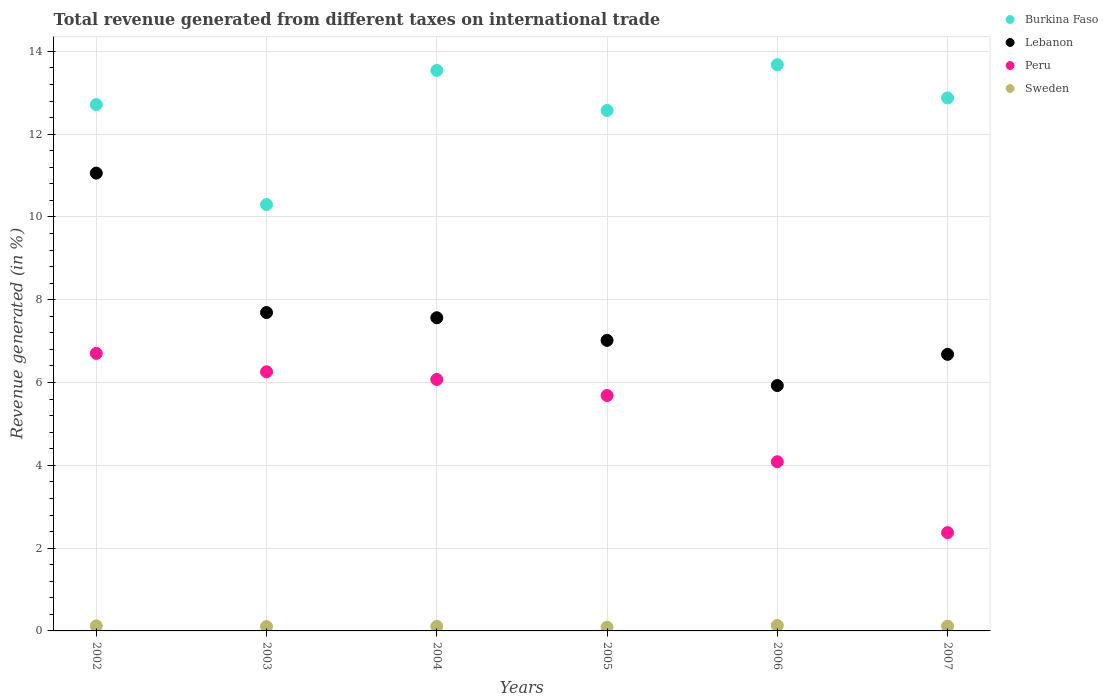How many different coloured dotlines are there?
Your response must be concise. 4. Is the number of dotlines equal to the number of legend labels?
Ensure brevity in your answer.  Yes. What is the total revenue generated in Burkina Faso in 2002?
Give a very brief answer. 12.71. Across all years, what is the maximum total revenue generated in Burkina Faso?
Ensure brevity in your answer.  13.68. Across all years, what is the minimum total revenue generated in Lebanon?
Offer a terse response. 5.93. In which year was the total revenue generated in Burkina Faso maximum?
Make the answer very short. 2006. What is the total total revenue generated in Lebanon in the graph?
Your answer should be very brief. 45.94. What is the difference between the total revenue generated in Peru in 2002 and that in 2006?
Give a very brief answer. 2.62. What is the difference between the total revenue generated in Lebanon in 2002 and the total revenue generated in Sweden in 2005?
Keep it short and to the point. 10.97. What is the average total revenue generated in Lebanon per year?
Give a very brief answer. 7.66. In the year 2004, what is the difference between the total revenue generated in Lebanon and total revenue generated in Peru?
Your response must be concise. 1.49. In how many years, is the total revenue generated in Burkina Faso greater than 4.8 %?
Make the answer very short. 6. What is the ratio of the total revenue generated in Burkina Faso in 2004 to that in 2005?
Your answer should be compact. 1.08. What is the difference between the highest and the second highest total revenue generated in Burkina Faso?
Your answer should be compact. 0.14. What is the difference between the highest and the lowest total revenue generated in Lebanon?
Offer a very short reply. 5.13. In how many years, is the total revenue generated in Sweden greater than the average total revenue generated in Sweden taken over all years?
Your response must be concise. 3. Is the sum of the total revenue generated in Peru in 2004 and 2006 greater than the maximum total revenue generated in Burkina Faso across all years?
Your answer should be compact. No. Is it the case that in every year, the sum of the total revenue generated in Burkina Faso and total revenue generated in Lebanon  is greater than the sum of total revenue generated in Peru and total revenue generated in Sweden?
Give a very brief answer. Yes. Is the total revenue generated in Sweden strictly less than the total revenue generated in Peru over the years?
Ensure brevity in your answer.  Yes. How many dotlines are there?
Your answer should be very brief. 4. Are the values on the major ticks of Y-axis written in scientific E-notation?
Your answer should be compact. No. Does the graph contain grids?
Keep it short and to the point. Yes. Where does the legend appear in the graph?
Ensure brevity in your answer.  Top right. What is the title of the graph?
Give a very brief answer. Total revenue generated from different taxes on international trade. What is the label or title of the Y-axis?
Keep it short and to the point. Revenue generated (in %). What is the Revenue generated (in %) of Burkina Faso in 2002?
Provide a succinct answer. 12.71. What is the Revenue generated (in %) of Lebanon in 2002?
Your answer should be very brief. 11.06. What is the Revenue generated (in %) of Peru in 2002?
Provide a succinct answer. 6.7. What is the Revenue generated (in %) of Sweden in 2002?
Your answer should be very brief. 0.12. What is the Revenue generated (in %) of Burkina Faso in 2003?
Your response must be concise. 10.3. What is the Revenue generated (in %) of Lebanon in 2003?
Provide a succinct answer. 7.69. What is the Revenue generated (in %) in Peru in 2003?
Provide a succinct answer. 6.26. What is the Revenue generated (in %) of Sweden in 2003?
Provide a succinct answer. 0.11. What is the Revenue generated (in %) of Burkina Faso in 2004?
Keep it short and to the point. 13.54. What is the Revenue generated (in %) in Lebanon in 2004?
Provide a succinct answer. 7.57. What is the Revenue generated (in %) in Peru in 2004?
Ensure brevity in your answer.  6.08. What is the Revenue generated (in %) in Sweden in 2004?
Offer a terse response. 0.11. What is the Revenue generated (in %) in Burkina Faso in 2005?
Give a very brief answer. 12.57. What is the Revenue generated (in %) of Lebanon in 2005?
Give a very brief answer. 7.02. What is the Revenue generated (in %) of Peru in 2005?
Make the answer very short. 5.69. What is the Revenue generated (in %) of Sweden in 2005?
Provide a short and direct response. 0.09. What is the Revenue generated (in %) in Burkina Faso in 2006?
Ensure brevity in your answer.  13.68. What is the Revenue generated (in %) in Lebanon in 2006?
Give a very brief answer. 5.93. What is the Revenue generated (in %) in Peru in 2006?
Your answer should be compact. 4.09. What is the Revenue generated (in %) in Sweden in 2006?
Your answer should be very brief. 0.13. What is the Revenue generated (in %) of Burkina Faso in 2007?
Offer a very short reply. 12.88. What is the Revenue generated (in %) in Lebanon in 2007?
Give a very brief answer. 6.68. What is the Revenue generated (in %) of Peru in 2007?
Offer a terse response. 2.37. What is the Revenue generated (in %) in Sweden in 2007?
Your answer should be compact. 0.11. Across all years, what is the maximum Revenue generated (in %) in Burkina Faso?
Provide a succinct answer. 13.68. Across all years, what is the maximum Revenue generated (in %) of Lebanon?
Your answer should be very brief. 11.06. Across all years, what is the maximum Revenue generated (in %) in Peru?
Offer a very short reply. 6.7. Across all years, what is the maximum Revenue generated (in %) in Sweden?
Your answer should be very brief. 0.13. Across all years, what is the minimum Revenue generated (in %) in Burkina Faso?
Give a very brief answer. 10.3. Across all years, what is the minimum Revenue generated (in %) of Lebanon?
Ensure brevity in your answer.  5.93. Across all years, what is the minimum Revenue generated (in %) of Peru?
Make the answer very short. 2.37. Across all years, what is the minimum Revenue generated (in %) in Sweden?
Provide a short and direct response. 0.09. What is the total Revenue generated (in %) in Burkina Faso in the graph?
Make the answer very short. 75.68. What is the total Revenue generated (in %) of Lebanon in the graph?
Give a very brief answer. 45.94. What is the total Revenue generated (in %) in Peru in the graph?
Give a very brief answer. 31.19. What is the total Revenue generated (in %) in Sweden in the graph?
Provide a succinct answer. 0.67. What is the difference between the Revenue generated (in %) in Burkina Faso in 2002 and that in 2003?
Provide a succinct answer. 2.41. What is the difference between the Revenue generated (in %) of Lebanon in 2002 and that in 2003?
Offer a terse response. 3.37. What is the difference between the Revenue generated (in %) of Peru in 2002 and that in 2003?
Ensure brevity in your answer.  0.44. What is the difference between the Revenue generated (in %) of Sweden in 2002 and that in 2003?
Give a very brief answer. 0.02. What is the difference between the Revenue generated (in %) of Burkina Faso in 2002 and that in 2004?
Give a very brief answer. -0.83. What is the difference between the Revenue generated (in %) of Lebanon in 2002 and that in 2004?
Provide a succinct answer. 3.49. What is the difference between the Revenue generated (in %) of Peru in 2002 and that in 2004?
Give a very brief answer. 0.63. What is the difference between the Revenue generated (in %) of Sweden in 2002 and that in 2004?
Offer a terse response. 0.01. What is the difference between the Revenue generated (in %) of Burkina Faso in 2002 and that in 2005?
Your response must be concise. 0.14. What is the difference between the Revenue generated (in %) in Lebanon in 2002 and that in 2005?
Offer a very short reply. 4.04. What is the difference between the Revenue generated (in %) of Peru in 2002 and that in 2005?
Your response must be concise. 1.02. What is the difference between the Revenue generated (in %) of Sweden in 2002 and that in 2005?
Offer a terse response. 0.03. What is the difference between the Revenue generated (in %) in Burkina Faso in 2002 and that in 2006?
Provide a short and direct response. -0.96. What is the difference between the Revenue generated (in %) of Lebanon in 2002 and that in 2006?
Your response must be concise. 5.13. What is the difference between the Revenue generated (in %) in Peru in 2002 and that in 2006?
Make the answer very short. 2.62. What is the difference between the Revenue generated (in %) in Sweden in 2002 and that in 2006?
Your response must be concise. -0.01. What is the difference between the Revenue generated (in %) in Burkina Faso in 2002 and that in 2007?
Your answer should be compact. -0.16. What is the difference between the Revenue generated (in %) of Lebanon in 2002 and that in 2007?
Your answer should be very brief. 4.38. What is the difference between the Revenue generated (in %) in Peru in 2002 and that in 2007?
Your response must be concise. 4.33. What is the difference between the Revenue generated (in %) of Sweden in 2002 and that in 2007?
Ensure brevity in your answer.  0.01. What is the difference between the Revenue generated (in %) in Burkina Faso in 2003 and that in 2004?
Give a very brief answer. -3.24. What is the difference between the Revenue generated (in %) of Lebanon in 2003 and that in 2004?
Make the answer very short. 0.13. What is the difference between the Revenue generated (in %) in Peru in 2003 and that in 2004?
Make the answer very short. 0.19. What is the difference between the Revenue generated (in %) of Sweden in 2003 and that in 2004?
Your answer should be compact. -0. What is the difference between the Revenue generated (in %) in Burkina Faso in 2003 and that in 2005?
Make the answer very short. -2.27. What is the difference between the Revenue generated (in %) in Lebanon in 2003 and that in 2005?
Offer a very short reply. 0.67. What is the difference between the Revenue generated (in %) of Peru in 2003 and that in 2005?
Make the answer very short. 0.57. What is the difference between the Revenue generated (in %) in Sweden in 2003 and that in 2005?
Give a very brief answer. 0.02. What is the difference between the Revenue generated (in %) of Burkina Faso in 2003 and that in 2006?
Provide a short and direct response. -3.38. What is the difference between the Revenue generated (in %) in Lebanon in 2003 and that in 2006?
Ensure brevity in your answer.  1.76. What is the difference between the Revenue generated (in %) in Peru in 2003 and that in 2006?
Give a very brief answer. 2.17. What is the difference between the Revenue generated (in %) of Sweden in 2003 and that in 2006?
Make the answer very short. -0.03. What is the difference between the Revenue generated (in %) in Burkina Faso in 2003 and that in 2007?
Your answer should be very brief. -2.58. What is the difference between the Revenue generated (in %) in Lebanon in 2003 and that in 2007?
Your answer should be very brief. 1.01. What is the difference between the Revenue generated (in %) in Peru in 2003 and that in 2007?
Ensure brevity in your answer.  3.89. What is the difference between the Revenue generated (in %) in Sweden in 2003 and that in 2007?
Your answer should be very brief. -0.01. What is the difference between the Revenue generated (in %) in Burkina Faso in 2004 and that in 2005?
Offer a terse response. 0.97. What is the difference between the Revenue generated (in %) in Lebanon in 2004 and that in 2005?
Your answer should be very brief. 0.55. What is the difference between the Revenue generated (in %) of Peru in 2004 and that in 2005?
Ensure brevity in your answer.  0.39. What is the difference between the Revenue generated (in %) of Sweden in 2004 and that in 2005?
Provide a succinct answer. 0.02. What is the difference between the Revenue generated (in %) of Burkina Faso in 2004 and that in 2006?
Offer a very short reply. -0.14. What is the difference between the Revenue generated (in %) of Lebanon in 2004 and that in 2006?
Offer a very short reply. 1.64. What is the difference between the Revenue generated (in %) in Peru in 2004 and that in 2006?
Your response must be concise. 1.99. What is the difference between the Revenue generated (in %) in Sweden in 2004 and that in 2006?
Keep it short and to the point. -0.02. What is the difference between the Revenue generated (in %) in Burkina Faso in 2004 and that in 2007?
Make the answer very short. 0.67. What is the difference between the Revenue generated (in %) of Lebanon in 2004 and that in 2007?
Your answer should be compact. 0.88. What is the difference between the Revenue generated (in %) in Peru in 2004 and that in 2007?
Offer a very short reply. 3.7. What is the difference between the Revenue generated (in %) in Sweden in 2004 and that in 2007?
Your answer should be compact. -0.01. What is the difference between the Revenue generated (in %) in Burkina Faso in 2005 and that in 2006?
Make the answer very short. -1.11. What is the difference between the Revenue generated (in %) of Lebanon in 2005 and that in 2006?
Provide a succinct answer. 1.09. What is the difference between the Revenue generated (in %) in Peru in 2005 and that in 2006?
Offer a very short reply. 1.6. What is the difference between the Revenue generated (in %) of Sweden in 2005 and that in 2006?
Offer a very short reply. -0.04. What is the difference between the Revenue generated (in %) of Burkina Faso in 2005 and that in 2007?
Give a very brief answer. -0.3. What is the difference between the Revenue generated (in %) in Lebanon in 2005 and that in 2007?
Provide a succinct answer. 0.34. What is the difference between the Revenue generated (in %) of Peru in 2005 and that in 2007?
Make the answer very short. 3.31. What is the difference between the Revenue generated (in %) in Sweden in 2005 and that in 2007?
Keep it short and to the point. -0.02. What is the difference between the Revenue generated (in %) of Burkina Faso in 2006 and that in 2007?
Your response must be concise. 0.8. What is the difference between the Revenue generated (in %) in Lebanon in 2006 and that in 2007?
Ensure brevity in your answer.  -0.75. What is the difference between the Revenue generated (in %) of Peru in 2006 and that in 2007?
Your response must be concise. 1.71. What is the difference between the Revenue generated (in %) in Sweden in 2006 and that in 2007?
Your answer should be compact. 0.02. What is the difference between the Revenue generated (in %) of Burkina Faso in 2002 and the Revenue generated (in %) of Lebanon in 2003?
Offer a terse response. 5.02. What is the difference between the Revenue generated (in %) in Burkina Faso in 2002 and the Revenue generated (in %) in Peru in 2003?
Provide a short and direct response. 6.45. What is the difference between the Revenue generated (in %) of Burkina Faso in 2002 and the Revenue generated (in %) of Sweden in 2003?
Provide a succinct answer. 12.61. What is the difference between the Revenue generated (in %) in Lebanon in 2002 and the Revenue generated (in %) in Peru in 2003?
Provide a succinct answer. 4.8. What is the difference between the Revenue generated (in %) of Lebanon in 2002 and the Revenue generated (in %) of Sweden in 2003?
Ensure brevity in your answer.  10.95. What is the difference between the Revenue generated (in %) of Peru in 2002 and the Revenue generated (in %) of Sweden in 2003?
Offer a terse response. 6.6. What is the difference between the Revenue generated (in %) in Burkina Faso in 2002 and the Revenue generated (in %) in Lebanon in 2004?
Offer a very short reply. 5.15. What is the difference between the Revenue generated (in %) of Burkina Faso in 2002 and the Revenue generated (in %) of Peru in 2004?
Give a very brief answer. 6.64. What is the difference between the Revenue generated (in %) of Burkina Faso in 2002 and the Revenue generated (in %) of Sweden in 2004?
Provide a succinct answer. 12.61. What is the difference between the Revenue generated (in %) in Lebanon in 2002 and the Revenue generated (in %) in Peru in 2004?
Your response must be concise. 4.98. What is the difference between the Revenue generated (in %) in Lebanon in 2002 and the Revenue generated (in %) in Sweden in 2004?
Provide a short and direct response. 10.95. What is the difference between the Revenue generated (in %) of Peru in 2002 and the Revenue generated (in %) of Sweden in 2004?
Provide a succinct answer. 6.6. What is the difference between the Revenue generated (in %) in Burkina Faso in 2002 and the Revenue generated (in %) in Lebanon in 2005?
Keep it short and to the point. 5.7. What is the difference between the Revenue generated (in %) of Burkina Faso in 2002 and the Revenue generated (in %) of Peru in 2005?
Your response must be concise. 7.03. What is the difference between the Revenue generated (in %) of Burkina Faso in 2002 and the Revenue generated (in %) of Sweden in 2005?
Provide a short and direct response. 12.62. What is the difference between the Revenue generated (in %) in Lebanon in 2002 and the Revenue generated (in %) in Peru in 2005?
Ensure brevity in your answer.  5.37. What is the difference between the Revenue generated (in %) in Lebanon in 2002 and the Revenue generated (in %) in Sweden in 2005?
Ensure brevity in your answer.  10.97. What is the difference between the Revenue generated (in %) of Peru in 2002 and the Revenue generated (in %) of Sweden in 2005?
Provide a short and direct response. 6.61. What is the difference between the Revenue generated (in %) in Burkina Faso in 2002 and the Revenue generated (in %) in Lebanon in 2006?
Keep it short and to the point. 6.79. What is the difference between the Revenue generated (in %) in Burkina Faso in 2002 and the Revenue generated (in %) in Peru in 2006?
Make the answer very short. 8.63. What is the difference between the Revenue generated (in %) in Burkina Faso in 2002 and the Revenue generated (in %) in Sweden in 2006?
Provide a succinct answer. 12.58. What is the difference between the Revenue generated (in %) of Lebanon in 2002 and the Revenue generated (in %) of Peru in 2006?
Ensure brevity in your answer.  6.97. What is the difference between the Revenue generated (in %) in Lebanon in 2002 and the Revenue generated (in %) in Sweden in 2006?
Ensure brevity in your answer.  10.93. What is the difference between the Revenue generated (in %) in Peru in 2002 and the Revenue generated (in %) in Sweden in 2006?
Ensure brevity in your answer.  6.57. What is the difference between the Revenue generated (in %) of Burkina Faso in 2002 and the Revenue generated (in %) of Lebanon in 2007?
Provide a succinct answer. 6.03. What is the difference between the Revenue generated (in %) of Burkina Faso in 2002 and the Revenue generated (in %) of Peru in 2007?
Keep it short and to the point. 10.34. What is the difference between the Revenue generated (in %) of Lebanon in 2002 and the Revenue generated (in %) of Peru in 2007?
Your answer should be compact. 8.68. What is the difference between the Revenue generated (in %) of Lebanon in 2002 and the Revenue generated (in %) of Sweden in 2007?
Offer a terse response. 10.94. What is the difference between the Revenue generated (in %) in Peru in 2002 and the Revenue generated (in %) in Sweden in 2007?
Give a very brief answer. 6.59. What is the difference between the Revenue generated (in %) of Burkina Faso in 2003 and the Revenue generated (in %) of Lebanon in 2004?
Provide a short and direct response. 2.73. What is the difference between the Revenue generated (in %) in Burkina Faso in 2003 and the Revenue generated (in %) in Peru in 2004?
Provide a succinct answer. 4.23. What is the difference between the Revenue generated (in %) of Burkina Faso in 2003 and the Revenue generated (in %) of Sweden in 2004?
Your answer should be very brief. 10.19. What is the difference between the Revenue generated (in %) of Lebanon in 2003 and the Revenue generated (in %) of Peru in 2004?
Ensure brevity in your answer.  1.62. What is the difference between the Revenue generated (in %) of Lebanon in 2003 and the Revenue generated (in %) of Sweden in 2004?
Offer a very short reply. 7.58. What is the difference between the Revenue generated (in %) of Peru in 2003 and the Revenue generated (in %) of Sweden in 2004?
Make the answer very short. 6.15. What is the difference between the Revenue generated (in %) of Burkina Faso in 2003 and the Revenue generated (in %) of Lebanon in 2005?
Your answer should be very brief. 3.28. What is the difference between the Revenue generated (in %) in Burkina Faso in 2003 and the Revenue generated (in %) in Peru in 2005?
Offer a very short reply. 4.61. What is the difference between the Revenue generated (in %) of Burkina Faso in 2003 and the Revenue generated (in %) of Sweden in 2005?
Offer a very short reply. 10.21. What is the difference between the Revenue generated (in %) in Lebanon in 2003 and the Revenue generated (in %) in Peru in 2005?
Make the answer very short. 2. What is the difference between the Revenue generated (in %) in Lebanon in 2003 and the Revenue generated (in %) in Sweden in 2005?
Make the answer very short. 7.6. What is the difference between the Revenue generated (in %) of Peru in 2003 and the Revenue generated (in %) of Sweden in 2005?
Your answer should be very brief. 6.17. What is the difference between the Revenue generated (in %) in Burkina Faso in 2003 and the Revenue generated (in %) in Lebanon in 2006?
Offer a very short reply. 4.37. What is the difference between the Revenue generated (in %) in Burkina Faso in 2003 and the Revenue generated (in %) in Peru in 2006?
Provide a short and direct response. 6.21. What is the difference between the Revenue generated (in %) of Burkina Faso in 2003 and the Revenue generated (in %) of Sweden in 2006?
Your response must be concise. 10.17. What is the difference between the Revenue generated (in %) in Lebanon in 2003 and the Revenue generated (in %) in Peru in 2006?
Provide a short and direct response. 3.6. What is the difference between the Revenue generated (in %) of Lebanon in 2003 and the Revenue generated (in %) of Sweden in 2006?
Give a very brief answer. 7.56. What is the difference between the Revenue generated (in %) of Peru in 2003 and the Revenue generated (in %) of Sweden in 2006?
Give a very brief answer. 6.13. What is the difference between the Revenue generated (in %) of Burkina Faso in 2003 and the Revenue generated (in %) of Lebanon in 2007?
Keep it short and to the point. 3.62. What is the difference between the Revenue generated (in %) of Burkina Faso in 2003 and the Revenue generated (in %) of Peru in 2007?
Ensure brevity in your answer.  7.93. What is the difference between the Revenue generated (in %) of Burkina Faso in 2003 and the Revenue generated (in %) of Sweden in 2007?
Your answer should be compact. 10.19. What is the difference between the Revenue generated (in %) in Lebanon in 2003 and the Revenue generated (in %) in Peru in 2007?
Ensure brevity in your answer.  5.32. What is the difference between the Revenue generated (in %) in Lebanon in 2003 and the Revenue generated (in %) in Sweden in 2007?
Offer a very short reply. 7.58. What is the difference between the Revenue generated (in %) of Peru in 2003 and the Revenue generated (in %) of Sweden in 2007?
Offer a very short reply. 6.15. What is the difference between the Revenue generated (in %) in Burkina Faso in 2004 and the Revenue generated (in %) in Lebanon in 2005?
Keep it short and to the point. 6.52. What is the difference between the Revenue generated (in %) of Burkina Faso in 2004 and the Revenue generated (in %) of Peru in 2005?
Your answer should be compact. 7.85. What is the difference between the Revenue generated (in %) in Burkina Faso in 2004 and the Revenue generated (in %) in Sweden in 2005?
Provide a succinct answer. 13.45. What is the difference between the Revenue generated (in %) of Lebanon in 2004 and the Revenue generated (in %) of Peru in 2005?
Make the answer very short. 1.88. What is the difference between the Revenue generated (in %) in Lebanon in 2004 and the Revenue generated (in %) in Sweden in 2005?
Your response must be concise. 7.48. What is the difference between the Revenue generated (in %) in Peru in 2004 and the Revenue generated (in %) in Sweden in 2005?
Your answer should be very brief. 5.99. What is the difference between the Revenue generated (in %) of Burkina Faso in 2004 and the Revenue generated (in %) of Lebanon in 2006?
Give a very brief answer. 7.61. What is the difference between the Revenue generated (in %) in Burkina Faso in 2004 and the Revenue generated (in %) in Peru in 2006?
Ensure brevity in your answer.  9.45. What is the difference between the Revenue generated (in %) of Burkina Faso in 2004 and the Revenue generated (in %) of Sweden in 2006?
Keep it short and to the point. 13.41. What is the difference between the Revenue generated (in %) of Lebanon in 2004 and the Revenue generated (in %) of Peru in 2006?
Your answer should be very brief. 3.48. What is the difference between the Revenue generated (in %) in Lebanon in 2004 and the Revenue generated (in %) in Sweden in 2006?
Keep it short and to the point. 7.43. What is the difference between the Revenue generated (in %) in Peru in 2004 and the Revenue generated (in %) in Sweden in 2006?
Your answer should be very brief. 5.94. What is the difference between the Revenue generated (in %) in Burkina Faso in 2004 and the Revenue generated (in %) in Lebanon in 2007?
Make the answer very short. 6.86. What is the difference between the Revenue generated (in %) in Burkina Faso in 2004 and the Revenue generated (in %) in Peru in 2007?
Your answer should be compact. 11.17. What is the difference between the Revenue generated (in %) in Burkina Faso in 2004 and the Revenue generated (in %) in Sweden in 2007?
Keep it short and to the point. 13.43. What is the difference between the Revenue generated (in %) in Lebanon in 2004 and the Revenue generated (in %) in Peru in 2007?
Give a very brief answer. 5.19. What is the difference between the Revenue generated (in %) of Lebanon in 2004 and the Revenue generated (in %) of Sweden in 2007?
Your response must be concise. 7.45. What is the difference between the Revenue generated (in %) of Peru in 2004 and the Revenue generated (in %) of Sweden in 2007?
Keep it short and to the point. 5.96. What is the difference between the Revenue generated (in %) in Burkina Faso in 2005 and the Revenue generated (in %) in Lebanon in 2006?
Provide a short and direct response. 6.65. What is the difference between the Revenue generated (in %) of Burkina Faso in 2005 and the Revenue generated (in %) of Peru in 2006?
Give a very brief answer. 8.49. What is the difference between the Revenue generated (in %) of Burkina Faso in 2005 and the Revenue generated (in %) of Sweden in 2006?
Your answer should be compact. 12.44. What is the difference between the Revenue generated (in %) in Lebanon in 2005 and the Revenue generated (in %) in Peru in 2006?
Your answer should be compact. 2.93. What is the difference between the Revenue generated (in %) in Lebanon in 2005 and the Revenue generated (in %) in Sweden in 2006?
Offer a terse response. 6.89. What is the difference between the Revenue generated (in %) of Peru in 2005 and the Revenue generated (in %) of Sweden in 2006?
Offer a very short reply. 5.56. What is the difference between the Revenue generated (in %) of Burkina Faso in 2005 and the Revenue generated (in %) of Lebanon in 2007?
Offer a very short reply. 5.89. What is the difference between the Revenue generated (in %) in Burkina Faso in 2005 and the Revenue generated (in %) in Peru in 2007?
Ensure brevity in your answer.  10.2. What is the difference between the Revenue generated (in %) in Burkina Faso in 2005 and the Revenue generated (in %) in Sweden in 2007?
Your answer should be compact. 12.46. What is the difference between the Revenue generated (in %) in Lebanon in 2005 and the Revenue generated (in %) in Peru in 2007?
Your response must be concise. 4.64. What is the difference between the Revenue generated (in %) of Lebanon in 2005 and the Revenue generated (in %) of Sweden in 2007?
Your answer should be very brief. 6.9. What is the difference between the Revenue generated (in %) in Peru in 2005 and the Revenue generated (in %) in Sweden in 2007?
Offer a very short reply. 5.57. What is the difference between the Revenue generated (in %) of Burkina Faso in 2006 and the Revenue generated (in %) of Lebanon in 2007?
Give a very brief answer. 7. What is the difference between the Revenue generated (in %) of Burkina Faso in 2006 and the Revenue generated (in %) of Peru in 2007?
Provide a short and direct response. 11.3. What is the difference between the Revenue generated (in %) in Burkina Faso in 2006 and the Revenue generated (in %) in Sweden in 2007?
Your answer should be compact. 13.56. What is the difference between the Revenue generated (in %) of Lebanon in 2006 and the Revenue generated (in %) of Peru in 2007?
Keep it short and to the point. 3.55. What is the difference between the Revenue generated (in %) in Lebanon in 2006 and the Revenue generated (in %) in Sweden in 2007?
Offer a very short reply. 5.81. What is the difference between the Revenue generated (in %) of Peru in 2006 and the Revenue generated (in %) of Sweden in 2007?
Your answer should be compact. 3.97. What is the average Revenue generated (in %) of Burkina Faso per year?
Keep it short and to the point. 12.61. What is the average Revenue generated (in %) in Lebanon per year?
Offer a terse response. 7.66. What is the average Revenue generated (in %) of Peru per year?
Keep it short and to the point. 5.2. What is the average Revenue generated (in %) of Sweden per year?
Provide a short and direct response. 0.11. In the year 2002, what is the difference between the Revenue generated (in %) of Burkina Faso and Revenue generated (in %) of Lebanon?
Your response must be concise. 1.66. In the year 2002, what is the difference between the Revenue generated (in %) in Burkina Faso and Revenue generated (in %) in Peru?
Your response must be concise. 6.01. In the year 2002, what is the difference between the Revenue generated (in %) in Burkina Faso and Revenue generated (in %) in Sweden?
Ensure brevity in your answer.  12.59. In the year 2002, what is the difference between the Revenue generated (in %) in Lebanon and Revenue generated (in %) in Peru?
Your response must be concise. 4.36. In the year 2002, what is the difference between the Revenue generated (in %) of Lebanon and Revenue generated (in %) of Sweden?
Make the answer very short. 10.94. In the year 2002, what is the difference between the Revenue generated (in %) in Peru and Revenue generated (in %) in Sweden?
Offer a very short reply. 6.58. In the year 2003, what is the difference between the Revenue generated (in %) of Burkina Faso and Revenue generated (in %) of Lebanon?
Offer a very short reply. 2.61. In the year 2003, what is the difference between the Revenue generated (in %) of Burkina Faso and Revenue generated (in %) of Peru?
Keep it short and to the point. 4.04. In the year 2003, what is the difference between the Revenue generated (in %) in Burkina Faso and Revenue generated (in %) in Sweden?
Your response must be concise. 10.19. In the year 2003, what is the difference between the Revenue generated (in %) in Lebanon and Revenue generated (in %) in Peru?
Offer a very short reply. 1.43. In the year 2003, what is the difference between the Revenue generated (in %) in Lebanon and Revenue generated (in %) in Sweden?
Your answer should be compact. 7.59. In the year 2003, what is the difference between the Revenue generated (in %) of Peru and Revenue generated (in %) of Sweden?
Provide a short and direct response. 6.15. In the year 2004, what is the difference between the Revenue generated (in %) in Burkina Faso and Revenue generated (in %) in Lebanon?
Provide a succinct answer. 5.98. In the year 2004, what is the difference between the Revenue generated (in %) of Burkina Faso and Revenue generated (in %) of Peru?
Ensure brevity in your answer.  7.47. In the year 2004, what is the difference between the Revenue generated (in %) in Burkina Faso and Revenue generated (in %) in Sweden?
Provide a succinct answer. 13.43. In the year 2004, what is the difference between the Revenue generated (in %) of Lebanon and Revenue generated (in %) of Peru?
Give a very brief answer. 1.49. In the year 2004, what is the difference between the Revenue generated (in %) in Lebanon and Revenue generated (in %) in Sweden?
Your answer should be very brief. 7.46. In the year 2004, what is the difference between the Revenue generated (in %) in Peru and Revenue generated (in %) in Sweden?
Provide a succinct answer. 5.97. In the year 2005, what is the difference between the Revenue generated (in %) in Burkina Faso and Revenue generated (in %) in Lebanon?
Your response must be concise. 5.55. In the year 2005, what is the difference between the Revenue generated (in %) of Burkina Faso and Revenue generated (in %) of Peru?
Provide a succinct answer. 6.89. In the year 2005, what is the difference between the Revenue generated (in %) in Burkina Faso and Revenue generated (in %) in Sweden?
Ensure brevity in your answer.  12.48. In the year 2005, what is the difference between the Revenue generated (in %) in Lebanon and Revenue generated (in %) in Peru?
Keep it short and to the point. 1.33. In the year 2005, what is the difference between the Revenue generated (in %) of Lebanon and Revenue generated (in %) of Sweden?
Offer a very short reply. 6.93. In the year 2005, what is the difference between the Revenue generated (in %) in Peru and Revenue generated (in %) in Sweden?
Offer a very short reply. 5.6. In the year 2006, what is the difference between the Revenue generated (in %) in Burkina Faso and Revenue generated (in %) in Lebanon?
Offer a very short reply. 7.75. In the year 2006, what is the difference between the Revenue generated (in %) in Burkina Faso and Revenue generated (in %) in Peru?
Your answer should be very brief. 9.59. In the year 2006, what is the difference between the Revenue generated (in %) of Burkina Faso and Revenue generated (in %) of Sweden?
Ensure brevity in your answer.  13.55. In the year 2006, what is the difference between the Revenue generated (in %) in Lebanon and Revenue generated (in %) in Peru?
Provide a succinct answer. 1.84. In the year 2006, what is the difference between the Revenue generated (in %) of Lebanon and Revenue generated (in %) of Sweden?
Provide a short and direct response. 5.8. In the year 2006, what is the difference between the Revenue generated (in %) of Peru and Revenue generated (in %) of Sweden?
Offer a very short reply. 3.96. In the year 2007, what is the difference between the Revenue generated (in %) of Burkina Faso and Revenue generated (in %) of Lebanon?
Ensure brevity in your answer.  6.19. In the year 2007, what is the difference between the Revenue generated (in %) in Burkina Faso and Revenue generated (in %) in Peru?
Provide a short and direct response. 10.5. In the year 2007, what is the difference between the Revenue generated (in %) in Burkina Faso and Revenue generated (in %) in Sweden?
Keep it short and to the point. 12.76. In the year 2007, what is the difference between the Revenue generated (in %) of Lebanon and Revenue generated (in %) of Peru?
Provide a succinct answer. 4.31. In the year 2007, what is the difference between the Revenue generated (in %) in Lebanon and Revenue generated (in %) in Sweden?
Provide a short and direct response. 6.57. In the year 2007, what is the difference between the Revenue generated (in %) of Peru and Revenue generated (in %) of Sweden?
Ensure brevity in your answer.  2.26. What is the ratio of the Revenue generated (in %) of Burkina Faso in 2002 to that in 2003?
Make the answer very short. 1.23. What is the ratio of the Revenue generated (in %) in Lebanon in 2002 to that in 2003?
Your response must be concise. 1.44. What is the ratio of the Revenue generated (in %) in Peru in 2002 to that in 2003?
Your response must be concise. 1.07. What is the ratio of the Revenue generated (in %) in Sweden in 2002 to that in 2003?
Give a very brief answer. 1.15. What is the ratio of the Revenue generated (in %) in Burkina Faso in 2002 to that in 2004?
Ensure brevity in your answer.  0.94. What is the ratio of the Revenue generated (in %) of Lebanon in 2002 to that in 2004?
Ensure brevity in your answer.  1.46. What is the ratio of the Revenue generated (in %) of Peru in 2002 to that in 2004?
Make the answer very short. 1.1. What is the ratio of the Revenue generated (in %) in Sweden in 2002 to that in 2004?
Provide a short and direct response. 1.11. What is the ratio of the Revenue generated (in %) in Burkina Faso in 2002 to that in 2005?
Make the answer very short. 1.01. What is the ratio of the Revenue generated (in %) in Lebanon in 2002 to that in 2005?
Offer a very short reply. 1.58. What is the ratio of the Revenue generated (in %) of Peru in 2002 to that in 2005?
Your response must be concise. 1.18. What is the ratio of the Revenue generated (in %) in Sweden in 2002 to that in 2005?
Offer a very short reply. 1.35. What is the ratio of the Revenue generated (in %) in Burkina Faso in 2002 to that in 2006?
Your response must be concise. 0.93. What is the ratio of the Revenue generated (in %) in Lebanon in 2002 to that in 2006?
Keep it short and to the point. 1.87. What is the ratio of the Revenue generated (in %) in Peru in 2002 to that in 2006?
Keep it short and to the point. 1.64. What is the ratio of the Revenue generated (in %) of Sweden in 2002 to that in 2006?
Your response must be concise. 0.92. What is the ratio of the Revenue generated (in %) of Burkina Faso in 2002 to that in 2007?
Give a very brief answer. 0.99. What is the ratio of the Revenue generated (in %) of Lebanon in 2002 to that in 2007?
Your answer should be very brief. 1.66. What is the ratio of the Revenue generated (in %) in Peru in 2002 to that in 2007?
Provide a succinct answer. 2.82. What is the ratio of the Revenue generated (in %) in Sweden in 2002 to that in 2007?
Your answer should be compact. 1.06. What is the ratio of the Revenue generated (in %) of Burkina Faso in 2003 to that in 2004?
Provide a succinct answer. 0.76. What is the ratio of the Revenue generated (in %) in Lebanon in 2003 to that in 2004?
Your answer should be very brief. 1.02. What is the ratio of the Revenue generated (in %) in Peru in 2003 to that in 2004?
Your response must be concise. 1.03. What is the ratio of the Revenue generated (in %) in Sweden in 2003 to that in 2004?
Provide a succinct answer. 0.97. What is the ratio of the Revenue generated (in %) in Burkina Faso in 2003 to that in 2005?
Give a very brief answer. 0.82. What is the ratio of the Revenue generated (in %) of Lebanon in 2003 to that in 2005?
Give a very brief answer. 1.1. What is the ratio of the Revenue generated (in %) of Peru in 2003 to that in 2005?
Give a very brief answer. 1.1. What is the ratio of the Revenue generated (in %) of Sweden in 2003 to that in 2005?
Ensure brevity in your answer.  1.17. What is the ratio of the Revenue generated (in %) of Burkina Faso in 2003 to that in 2006?
Offer a very short reply. 0.75. What is the ratio of the Revenue generated (in %) in Lebanon in 2003 to that in 2006?
Give a very brief answer. 1.3. What is the ratio of the Revenue generated (in %) in Peru in 2003 to that in 2006?
Keep it short and to the point. 1.53. What is the ratio of the Revenue generated (in %) in Sweden in 2003 to that in 2006?
Make the answer very short. 0.8. What is the ratio of the Revenue generated (in %) in Lebanon in 2003 to that in 2007?
Your answer should be very brief. 1.15. What is the ratio of the Revenue generated (in %) in Peru in 2003 to that in 2007?
Provide a succinct answer. 2.64. What is the ratio of the Revenue generated (in %) in Sweden in 2003 to that in 2007?
Your answer should be very brief. 0.92. What is the ratio of the Revenue generated (in %) in Burkina Faso in 2004 to that in 2005?
Give a very brief answer. 1.08. What is the ratio of the Revenue generated (in %) in Lebanon in 2004 to that in 2005?
Provide a succinct answer. 1.08. What is the ratio of the Revenue generated (in %) of Peru in 2004 to that in 2005?
Give a very brief answer. 1.07. What is the ratio of the Revenue generated (in %) in Sweden in 2004 to that in 2005?
Your response must be concise. 1.21. What is the ratio of the Revenue generated (in %) in Burkina Faso in 2004 to that in 2006?
Make the answer very short. 0.99. What is the ratio of the Revenue generated (in %) of Lebanon in 2004 to that in 2006?
Offer a terse response. 1.28. What is the ratio of the Revenue generated (in %) of Peru in 2004 to that in 2006?
Ensure brevity in your answer.  1.49. What is the ratio of the Revenue generated (in %) in Sweden in 2004 to that in 2006?
Your answer should be compact. 0.83. What is the ratio of the Revenue generated (in %) in Burkina Faso in 2004 to that in 2007?
Your response must be concise. 1.05. What is the ratio of the Revenue generated (in %) in Lebanon in 2004 to that in 2007?
Ensure brevity in your answer.  1.13. What is the ratio of the Revenue generated (in %) of Peru in 2004 to that in 2007?
Provide a short and direct response. 2.56. What is the ratio of the Revenue generated (in %) of Sweden in 2004 to that in 2007?
Your response must be concise. 0.95. What is the ratio of the Revenue generated (in %) of Burkina Faso in 2005 to that in 2006?
Provide a short and direct response. 0.92. What is the ratio of the Revenue generated (in %) in Lebanon in 2005 to that in 2006?
Keep it short and to the point. 1.18. What is the ratio of the Revenue generated (in %) of Peru in 2005 to that in 2006?
Provide a short and direct response. 1.39. What is the ratio of the Revenue generated (in %) in Sweden in 2005 to that in 2006?
Your answer should be compact. 0.68. What is the ratio of the Revenue generated (in %) in Burkina Faso in 2005 to that in 2007?
Make the answer very short. 0.98. What is the ratio of the Revenue generated (in %) of Lebanon in 2005 to that in 2007?
Ensure brevity in your answer.  1.05. What is the ratio of the Revenue generated (in %) of Peru in 2005 to that in 2007?
Keep it short and to the point. 2.39. What is the ratio of the Revenue generated (in %) in Sweden in 2005 to that in 2007?
Offer a very short reply. 0.78. What is the ratio of the Revenue generated (in %) of Burkina Faso in 2006 to that in 2007?
Offer a very short reply. 1.06. What is the ratio of the Revenue generated (in %) of Lebanon in 2006 to that in 2007?
Your answer should be very brief. 0.89. What is the ratio of the Revenue generated (in %) in Peru in 2006 to that in 2007?
Ensure brevity in your answer.  1.72. What is the ratio of the Revenue generated (in %) of Sweden in 2006 to that in 2007?
Provide a short and direct response. 1.15. What is the difference between the highest and the second highest Revenue generated (in %) in Burkina Faso?
Offer a very short reply. 0.14. What is the difference between the highest and the second highest Revenue generated (in %) of Lebanon?
Provide a short and direct response. 3.37. What is the difference between the highest and the second highest Revenue generated (in %) in Peru?
Offer a terse response. 0.44. What is the difference between the highest and the second highest Revenue generated (in %) of Sweden?
Offer a very short reply. 0.01. What is the difference between the highest and the lowest Revenue generated (in %) in Burkina Faso?
Your response must be concise. 3.38. What is the difference between the highest and the lowest Revenue generated (in %) in Lebanon?
Offer a terse response. 5.13. What is the difference between the highest and the lowest Revenue generated (in %) of Peru?
Keep it short and to the point. 4.33. What is the difference between the highest and the lowest Revenue generated (in %) of Sweden?
Offer a terse response. 0.04. 